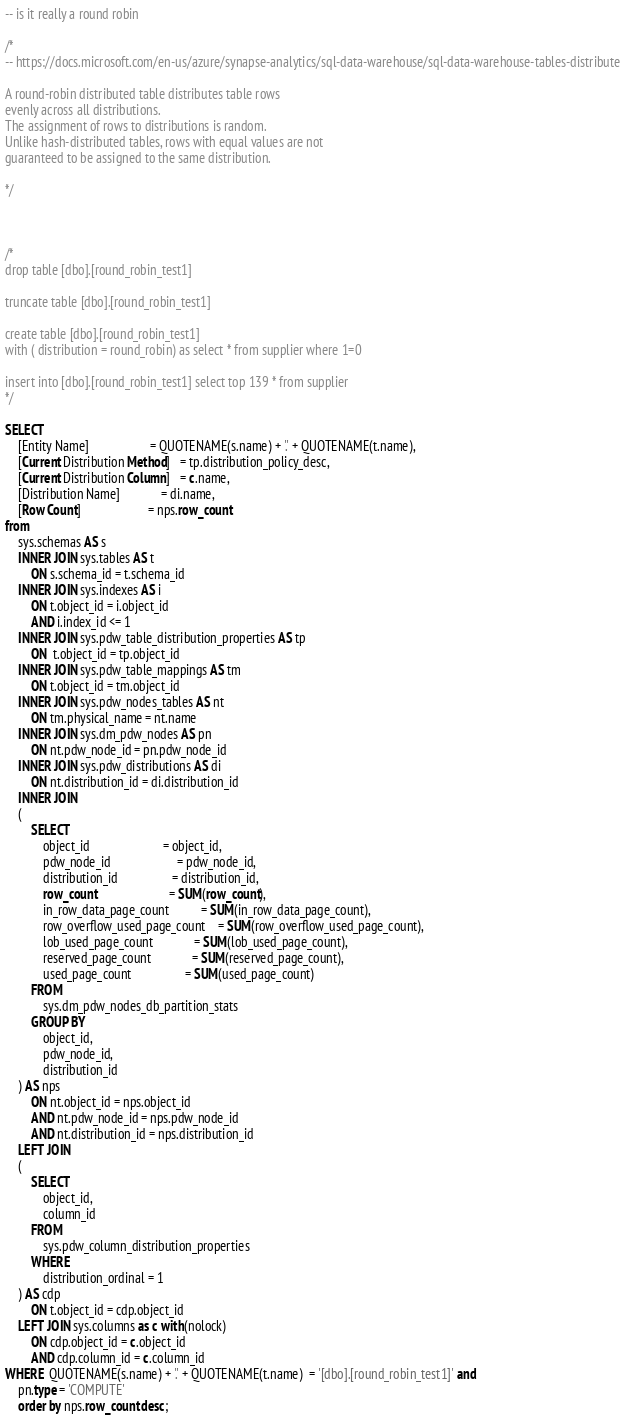Convert code to text. <code><loc_0><loc_0><loc_500><loc_500><_SQL_>-- is it really a round robin

/*
-- https://docs.microsoft.com/en-us/azure/synapse-analytics/sql-data-warehouse/sql-data-warehouse-tables-distribute

A round-robin distributed table distributes table rows 
evenly across all distributions. 
The assignment of rows to distributions is random. 
Unlike hash-distributed tables, rows with equal values are not 
guaranteed to be assigned to the same distribution.

*/



/*
drop table [dbo].[round_robin_test1] 

truncate table [dbo].[round_robin_test1] 

create table [dbo].[round_robin_test1]  
with ( distribution = round_robin) as select * from supplier where 1=0

insert into [dbo].[round_robin_test1] select top 139 * from supplier
*/

SELECT
    [Entity Name]                   = QUOTENAME(s.name) + '.' + QUOTENAME(t.name),
    [Current Distribution Method]   = tp.distribution_policy_desc,
    [Current Distribution Column]   = c.name,
    [Distribution Name]             = di.name,
    [Row Count]                     = nps.row_count
from
    sys.schemas AS s
    INNER JOIN sys.tables AS t
        ON s.schema_id = t.schema_id
    INNER JOIN sys.indexes AS i
        ON t.object_id = i.object_id
        AND i.index_id <= 1
    INNER JOIN sys.pdw_table_distribution_properties AS tp
        ON  t.object_id = tp.object_id
    INNER JOIN sys.pdw_table_mappings AS tm
        ON t.object_id = tm.object_id
    INNER JOIN sys.pdw_nodes_tables AS nt
        ON tm.physical_name = nt.name
    INNER JOIN sys.dm_pdw_nodes AS pn
        ON nt.pdw_node_id = pn.pdw_node_id
    INNER JOIN sys.pdw_distributions AS di
        ON nt.distribution_id = di.distribution_id
    INNER JOIN
    (
        SELECT
            object_id                       = object_id,
            pdw_node_id                     = pdw_node_id,
            distribution_id                 = distribution_id,
            row_count                       = SUM(row_count),
            in_row_data_page_count          = SUM(in_row_data_page_count),
            row_overflow_used_page_count    = SUM(row_overflow_used_page_count),
            lob_used_page_count             = SUM(lob_used_page_count),
            reserved_page_count             = SUM(reserved_page_count),
            used_page_count                 = SUM(used_page_count)
        FROM
            sys.dm_pdw_nodes_db_partition_stats
        GROUP BY
            object_id,
            pdw_node_id,
            distribution_id
    ) AS nps
        ON nt.object_id = nps.object_id
        AND nt.pdw_node_id = nps.pdw_node_id
        AND nt.distribution_id = nps.distribution_id
    LEFT JOIN
    (
        SELECT
            object_id,
            column_id
        FROM
            sys.pdw_column_distribution_properties
        WHERE
            distribution_ordinal = 1
    ) AS cdp
        ON t.object_id = cdp.object_id
    LEFT JOIN sys.columns as c with(nolock)
        ON cdp.object_id = c.object_id
        AND cdp.column_id = c.column_id
WHERE  QUOTENAME(s.name) + '.' + QUOTENAME(t.name)  = '[dbo].[round_robin_test1]' and
    pn.type = 'COMPUTE'
	order by nps.row_count desc;
</code> 